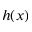<formula> <loc_0><loc_0><loc_500><loc_500>h ( x )</formula> 